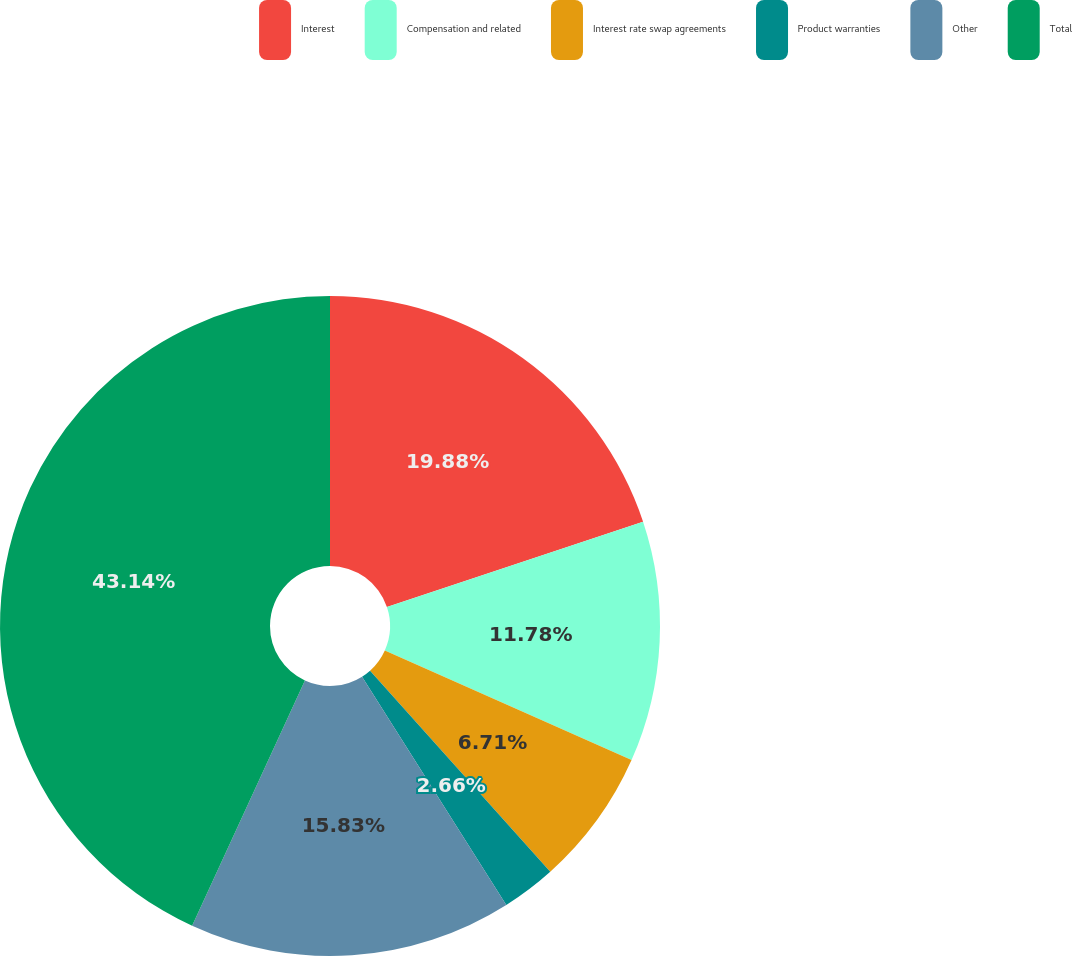Convert chart. <chart><loc_0><loc_0><loc_500><loc_500><pie_chart><fcel>Interest<fcel>Compensation and related<fcel>Interest rate swap agreements<fcel>Product warranties<fcel>Other<fcel>Total<nl><fcel>19.88%<fcel>11.78%<fcel>6.71%<fcel>2.66%<fcel>15.83%<fcel>43.14%<nl></chart> 